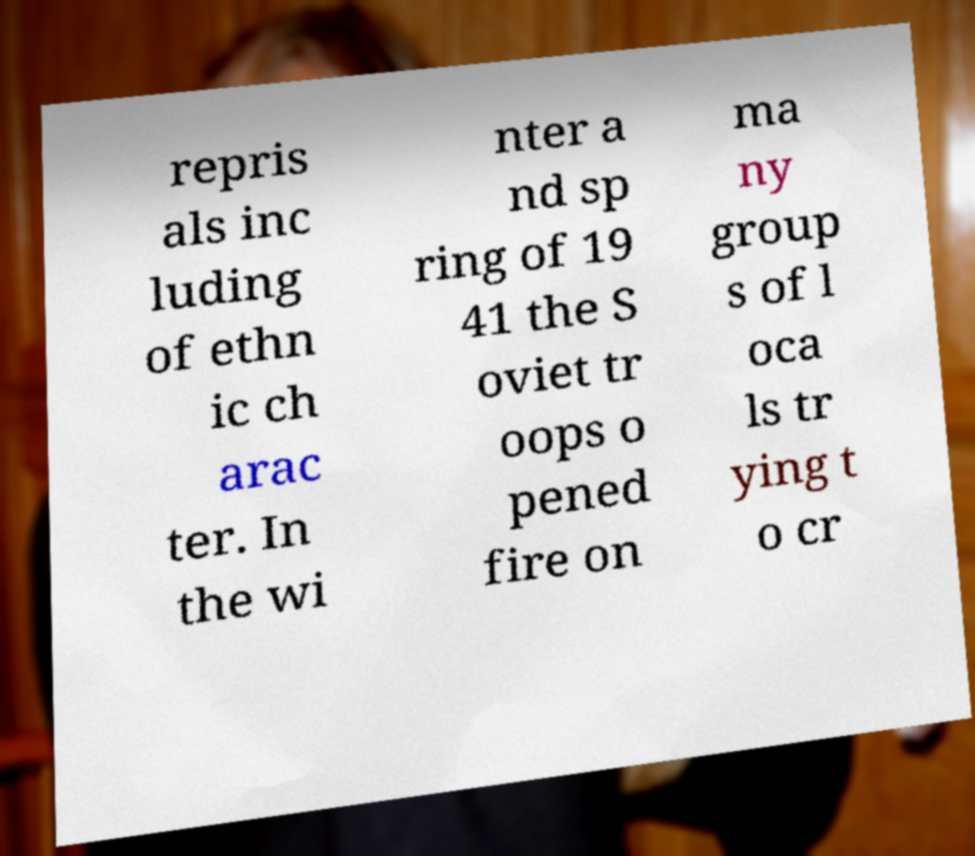Could you extract and type out the text from this image? repris als inc luding of ethn ic ch arac ter. In the wi nter a nd sp ring of 19 41 the S oviet tr oops o pened fire on ma ny group s of l oca ls tr ying t o cr 